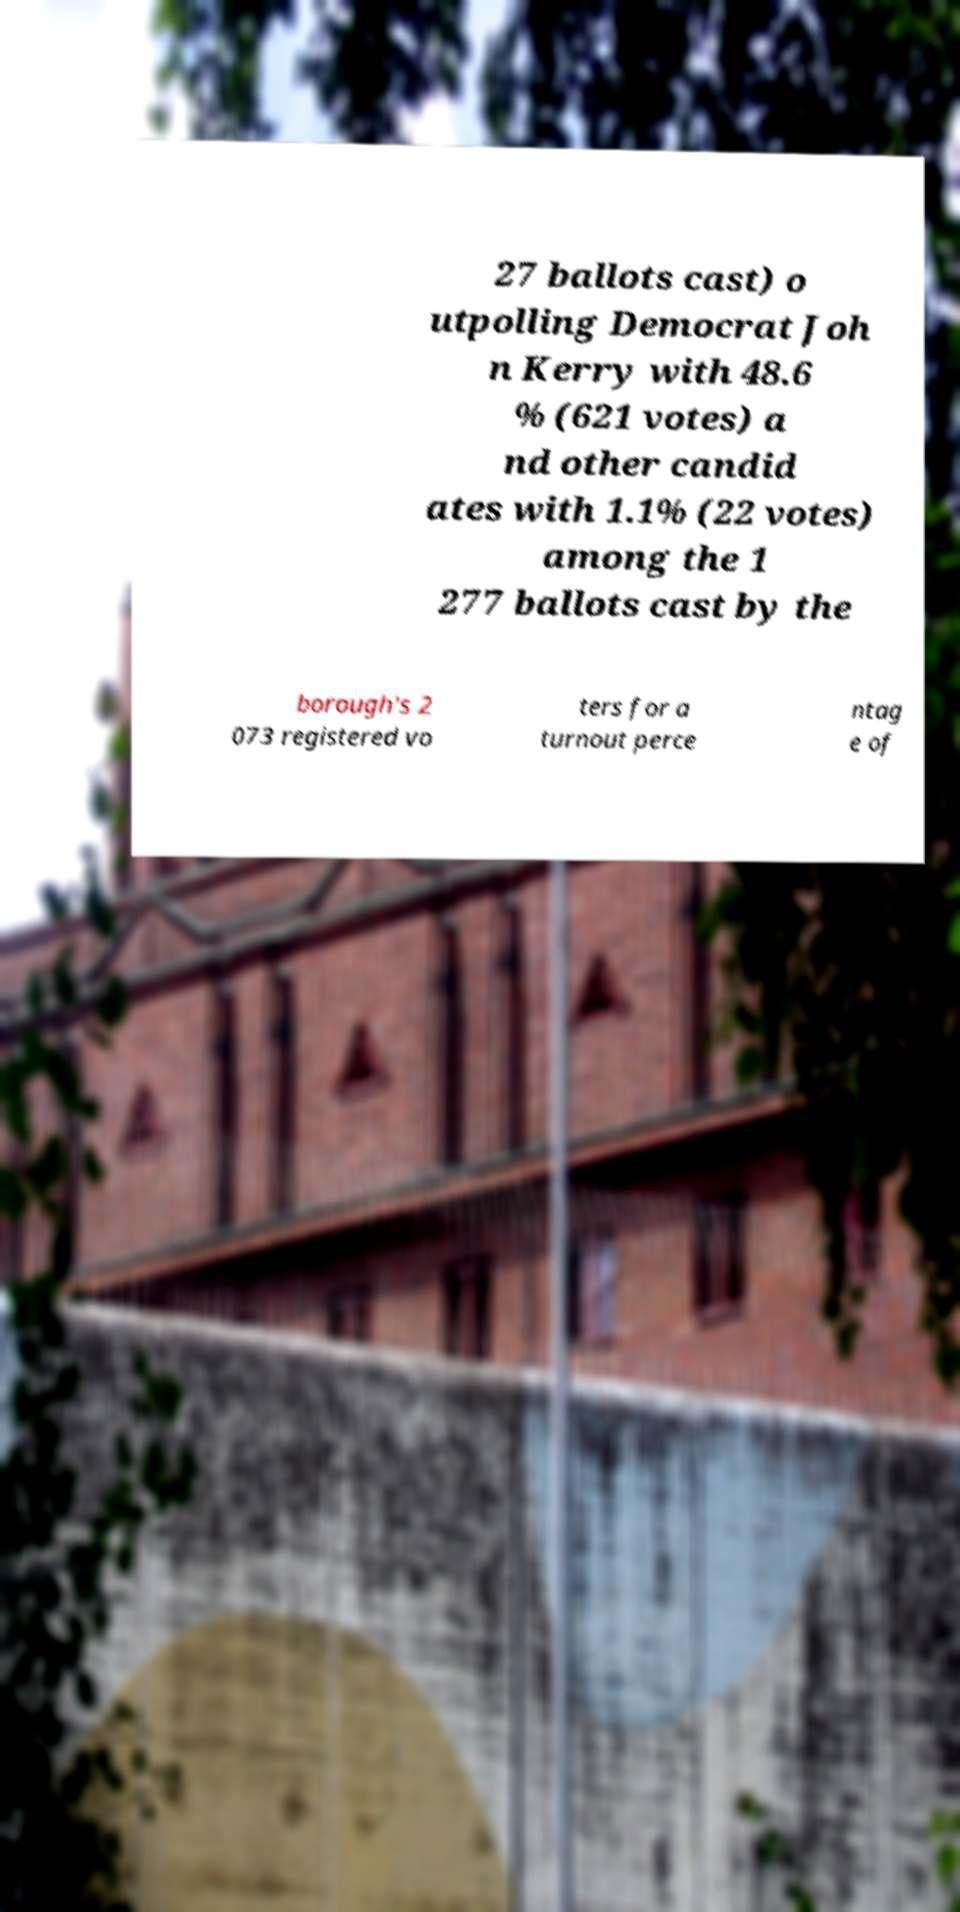I need the written content from this picture converted into text. Can you do that? 27 ballots cast) o utpolling Democrat Joh n Kerry with 48.6 % (621 votes) a nd other candid ates with 1.1% (22 votes) among the 1 277 ballots cast by the borough's 2 073 registered vo ters for a turnout perce ntag e of 